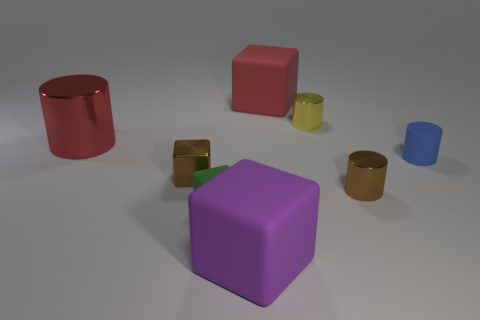There is a shiny cylinder that is the same color as the tiny metal block; what size is it?
Provide a short and direct response. Small. What size is the block that is to the right of the tiny matte block and behind the small green cube?
Provide a succinct answer. Large. How many tiny cylinders are left of the tiny green cube?
Make the answer very short. 0. Is the number of red metal cylinders greater than the number of yellow matte objects?
Give a very brief answer. Yes. The metal object that is both to the right of the red metal cylinder and left of the green cube has what shape?
Offer a terse response. Cube. Is there a large green rubber block?
Offer a terse response. No. There is a big purple object that is the same shape as the green matte object; what is it made of?
Provide a succinct answer. Rubber. What is the shape of the tiny rubber object to the left of the large matte object behind the large rubber block that is in front of the red metallic cylinder?
Provide a succinct answer. Cube. There is a tiny thing that is the same color as the metal cube; what is it made of?
Offer a very short reply. Metal. How many other small rubber things have the same shape as the purple thing?
Your response must be concise. 1. 